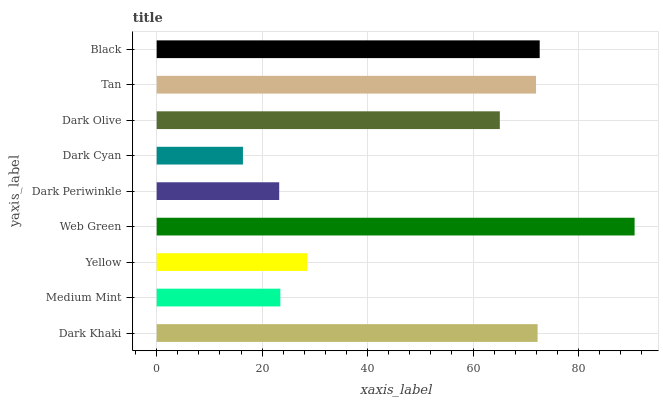Is Dark Cyan the minimum?
Answer yes or no. Yes. Is Web Green the maximum?
Answer yes or no. Yes. Is Medium Mint the minimum?
Answer yes or no. No. Is Medium Mint the maximum?
Answer yes or no. No. Is Dark Khaki greater than Medium Mint?
Answer yes or no. Yes. Is Medium Mint less than Dark Khaki?
Answer yes or no. Yes. Is Medium Mint greater than Dark Khaki?
Answer yes or no. No. Is Dark Khaki less than Medium Mint?
Answer yes or no. No. Is Dark Olive the high median?
Answer yes or no. Yes. Is Dark Olive the low median?
Answer yes or no. Yes. Is Medium Mint the high median?
Answer yes or no. No. Is Black the low median?
Answer yes or no. No. 